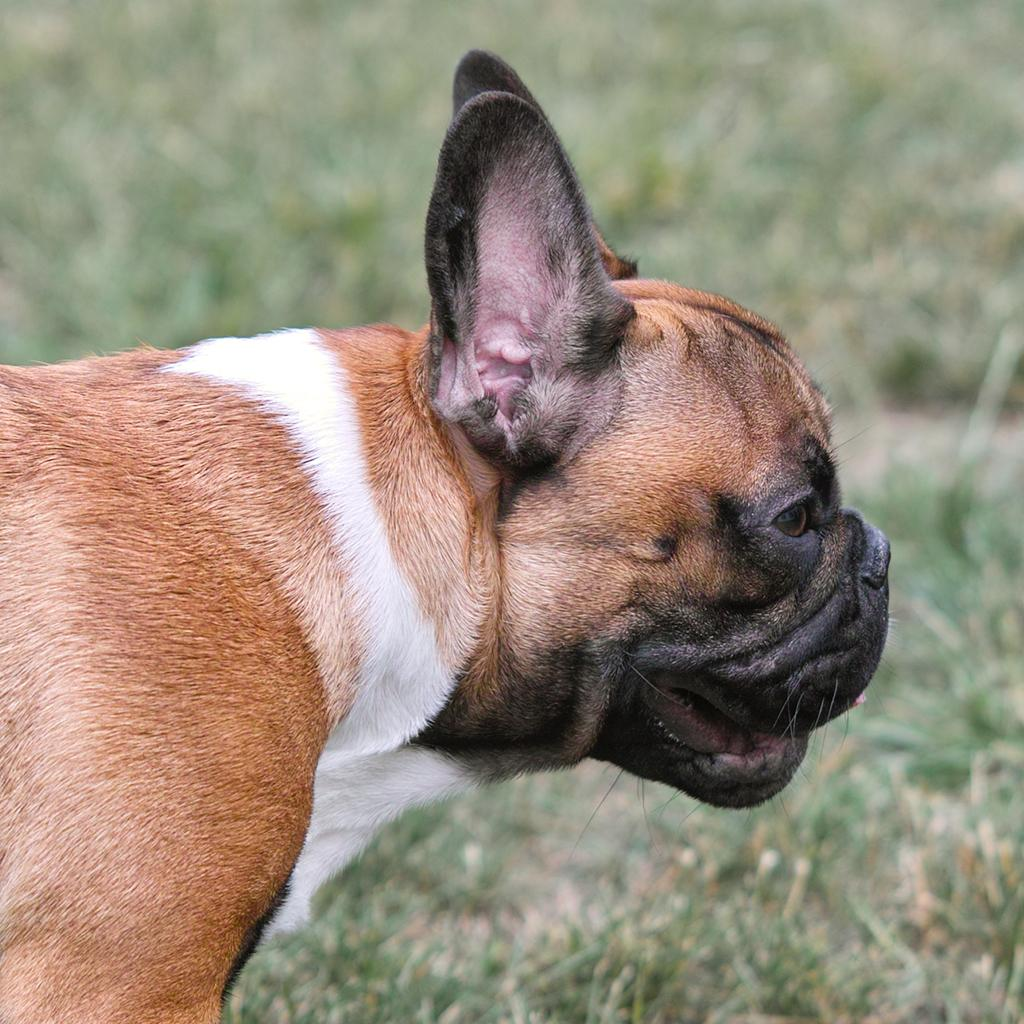What type of animal is in the image? There is a brown dog in the image. Can you describe the background of the image? The background of the image is blurred. What is the chance of the dog attacking a sock in the image? There is no sock present in the image, so it is not possible to determine the chance of the dog attacking a sock. 